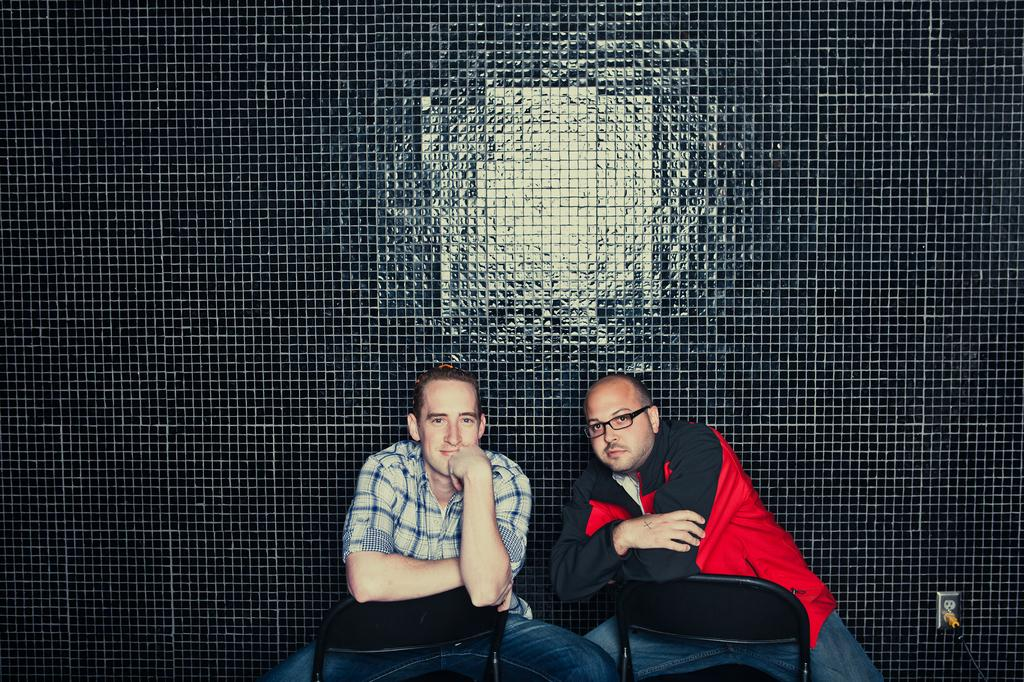How many people are in the image? There are two men in the image. What are the men doing in the image? The men are sitting on chairs. What can be seen in the background of the image? There is a black surface in the background of the image. What might the black surface be? The black surface appears to be a wall. How many trees can be seen in the image? There are no trees visible in the image. What type of spacecraft is present in the image? There is no spacecraft present in the image. 